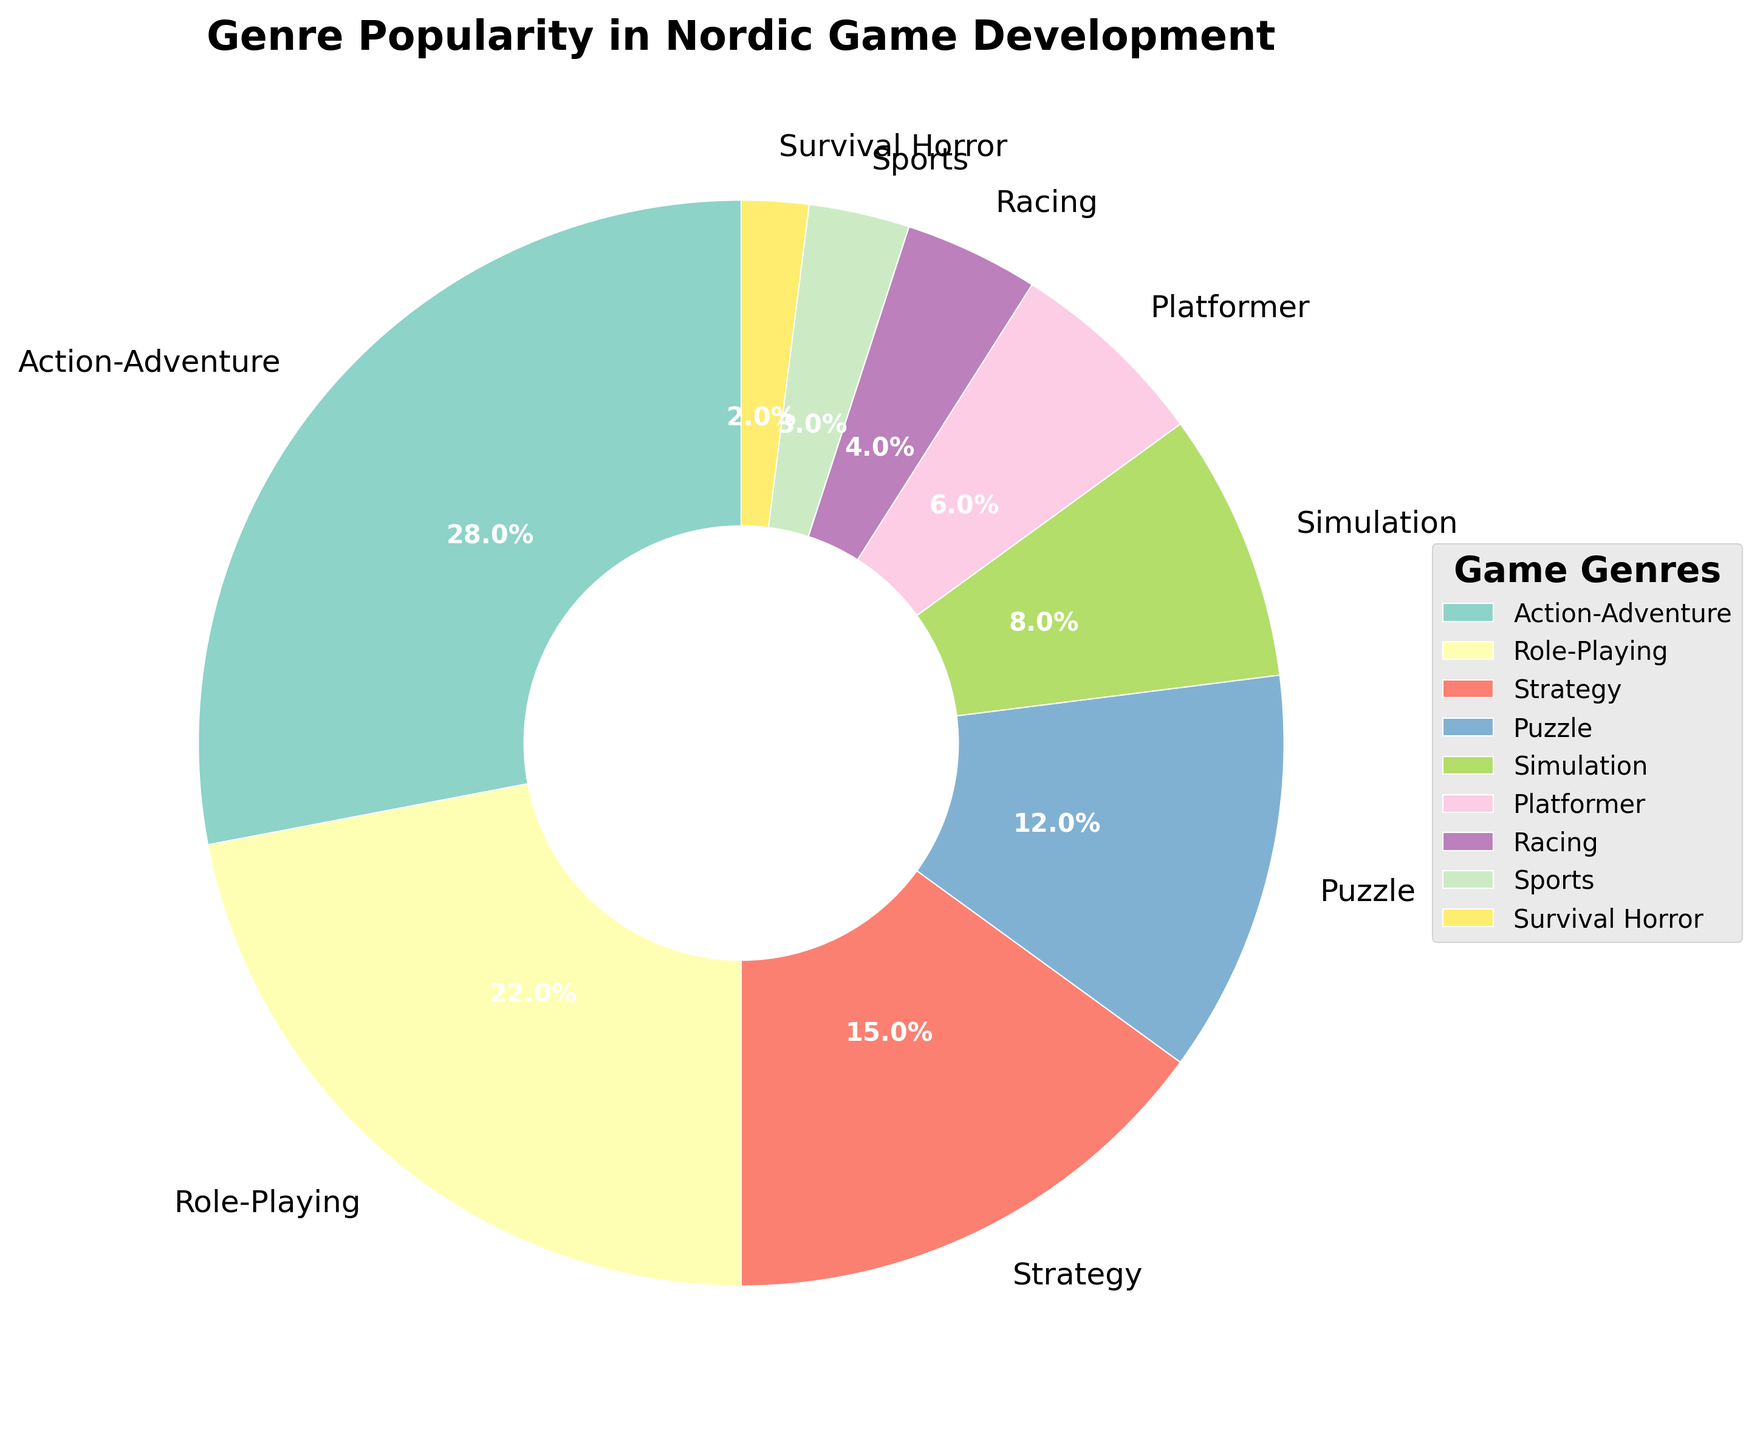What's the most popular genre according to the chart? The pie chart shows the percentage for each genre. The genre with the highest percentage is the most popular. In this case, Action-Adventure has the largest slice at 28%.
Answer: Action-Adventure What are the combined percentages of the Role-Playing, Simulation, and Sports genres? By adding the percentages of the Role-Playing (22%), Simulation (8%), and Sports (3%) genres together, we get 22% + 8% + 3% = 33%.
Answer: 33% Which genre has a slightly higher percentage, Strategy or Puzzle? The pie chart shows Strategy at 15% and Puzzle at 12%. Comparing these, Strategy has a slightly higher percentage.
Answer: Strategy How much more popular is Action-Adventure compared to Racing? Action-Adventure is at 28%, and Racing is at 4% in the pie chart. The difference between these percentages is 28% - 4% = 24%.
Answer: 24% Which genres occupy between 5% and 10% of the chart? The pie chart shows that Simulation has 8% and Platformer has 6%, both of which fall between 5% and 10%.
Answer: Simulation and Platformer 